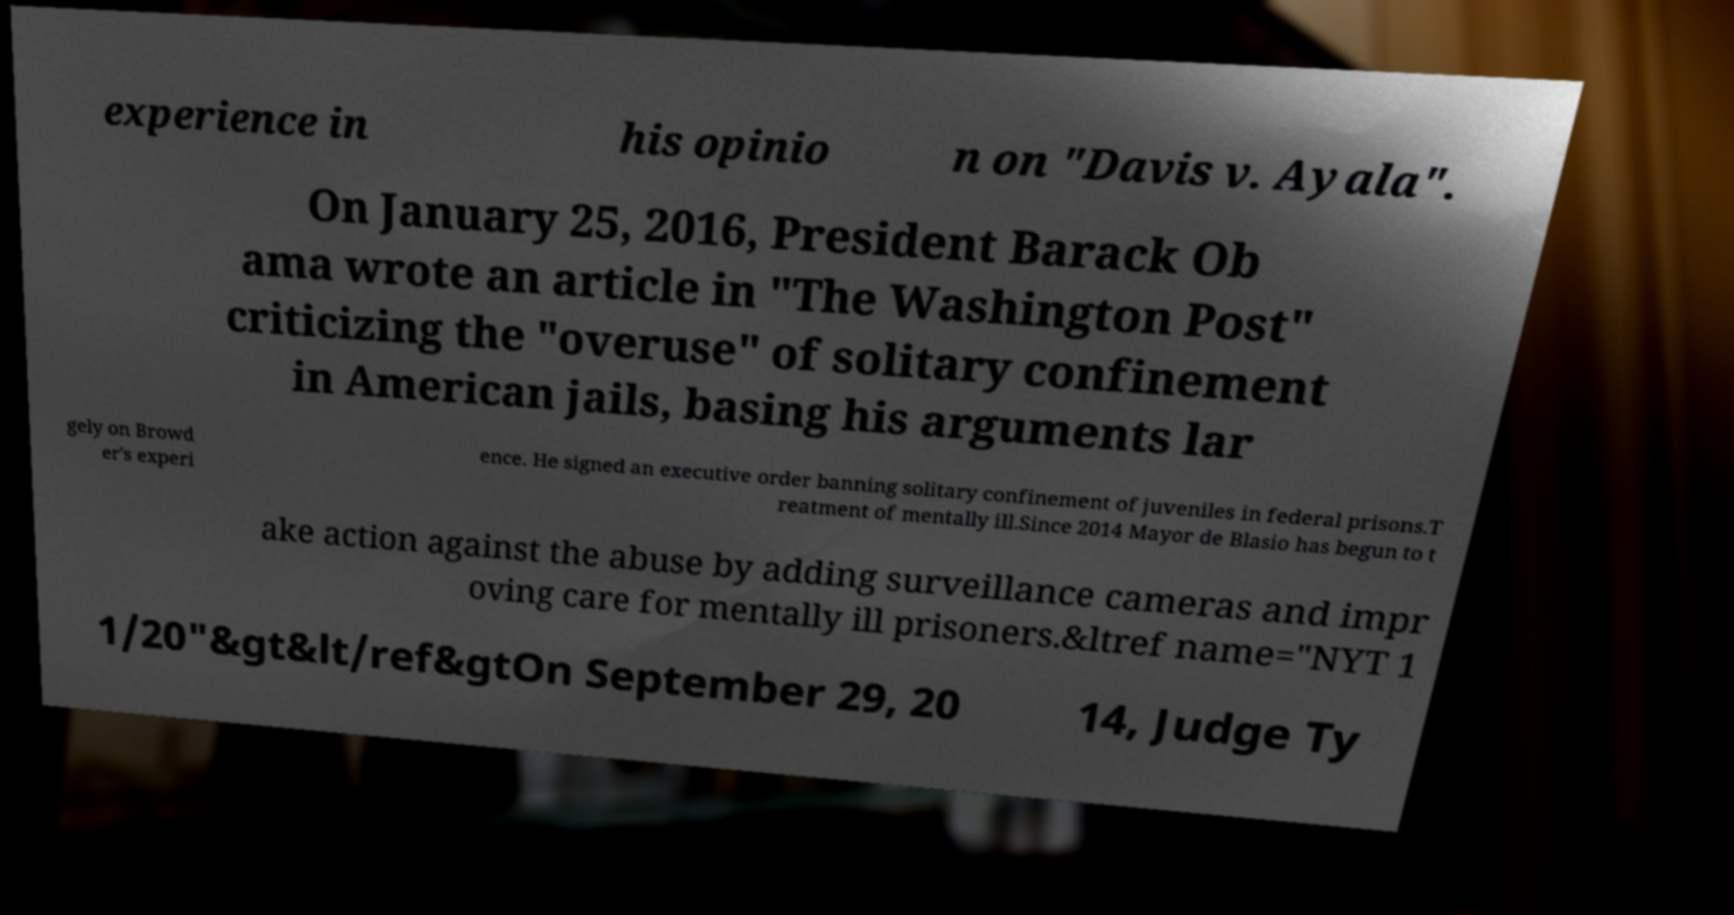Could you assist in decoding the text presented in this image and type it out clearly? experience in his opinio n on "Davis v. Ayala". On January 25, 2016, President Barack Ob ama wrote an article in "The Washington Post" criticizing the "overuse" of solitary confinement in American jails, basing his arguments lar gely on Browd er's experi ence. He signed an executive order banning solitary confinement of juveniles in federal prisons.T reatment of mentally ill.Since 2014 Mayor de Blasio has begun to t ake action against the abuse by adding surveillance cameras and impr oving care for mentally ill prisoners.&ltref name="NYT 1 1/20"&gt&lt/ref&gtOn September 29, 20 14, Judge Ty 